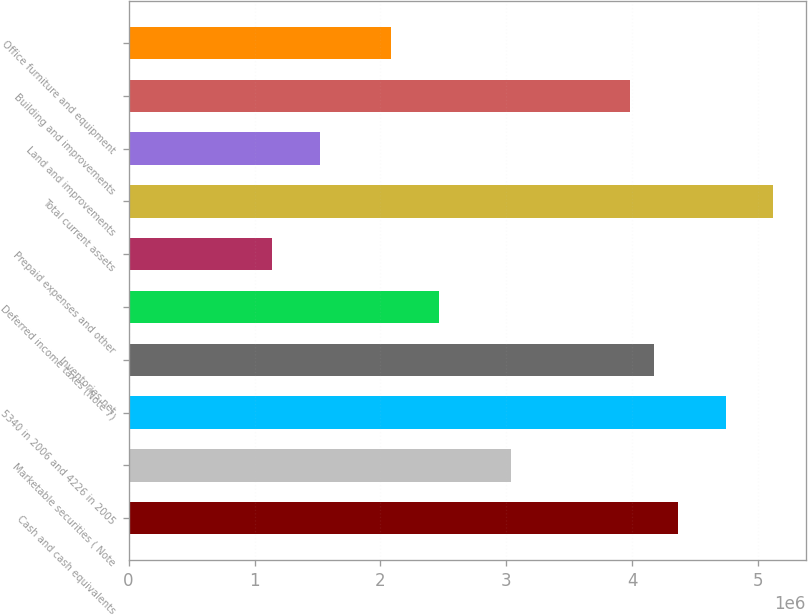Convert chart. <chart><loc_0><loc_0><loc_500><loc_500><bar_chart><fcel>Cash and cash equivalents<fcel>Marketable securities ( Note<fcel>5340 in 2006 and 4226 in 2005<fcel>Inventories net<fcel>Deferred income taxes (Note 7)<fcel>Prepaid expenses and other<fcel>Total current assets<fcel>Land and improvements<fcel>Building and improvements<fcel>Office furniture and equipment<nl><fcel>4.36174e+06<fcel>3.03458e+06<fcel>4.74093e+06<fcel>4.17215e+06<fcel>2.4658e+06<fcel>1.13864e+06<fcel>5.12011e+06<fcel>1.51783e+06<fcel>3.98255e+06<fcel>2.08661e+06<nl></chart> 